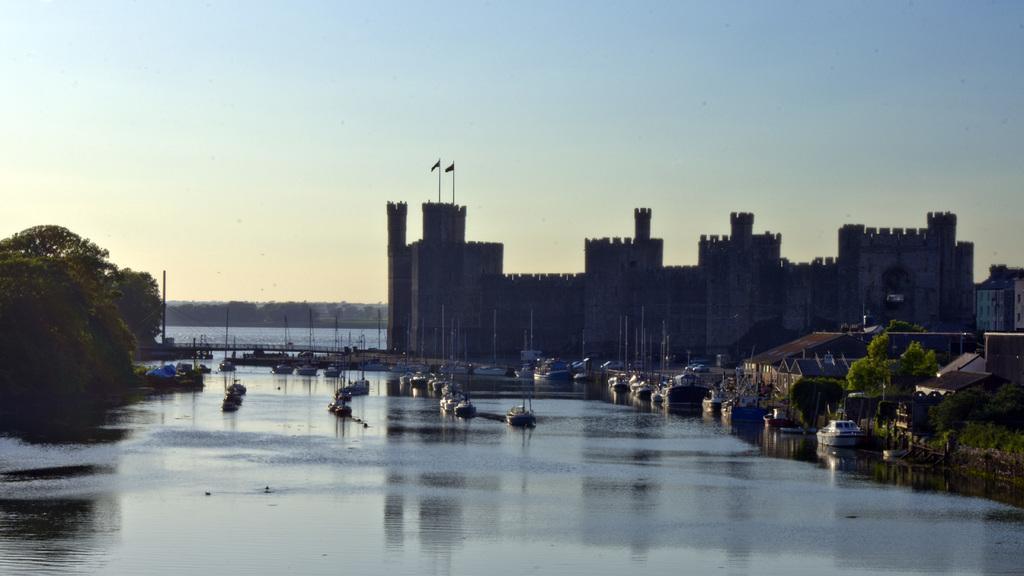Can you describe this image briefly? In this image we can see buildings. Bottom of the image sea is there. Right side of the image trees and boats are present on the surface of the water. Left side of the image trees are there. The sky is in blue color. 